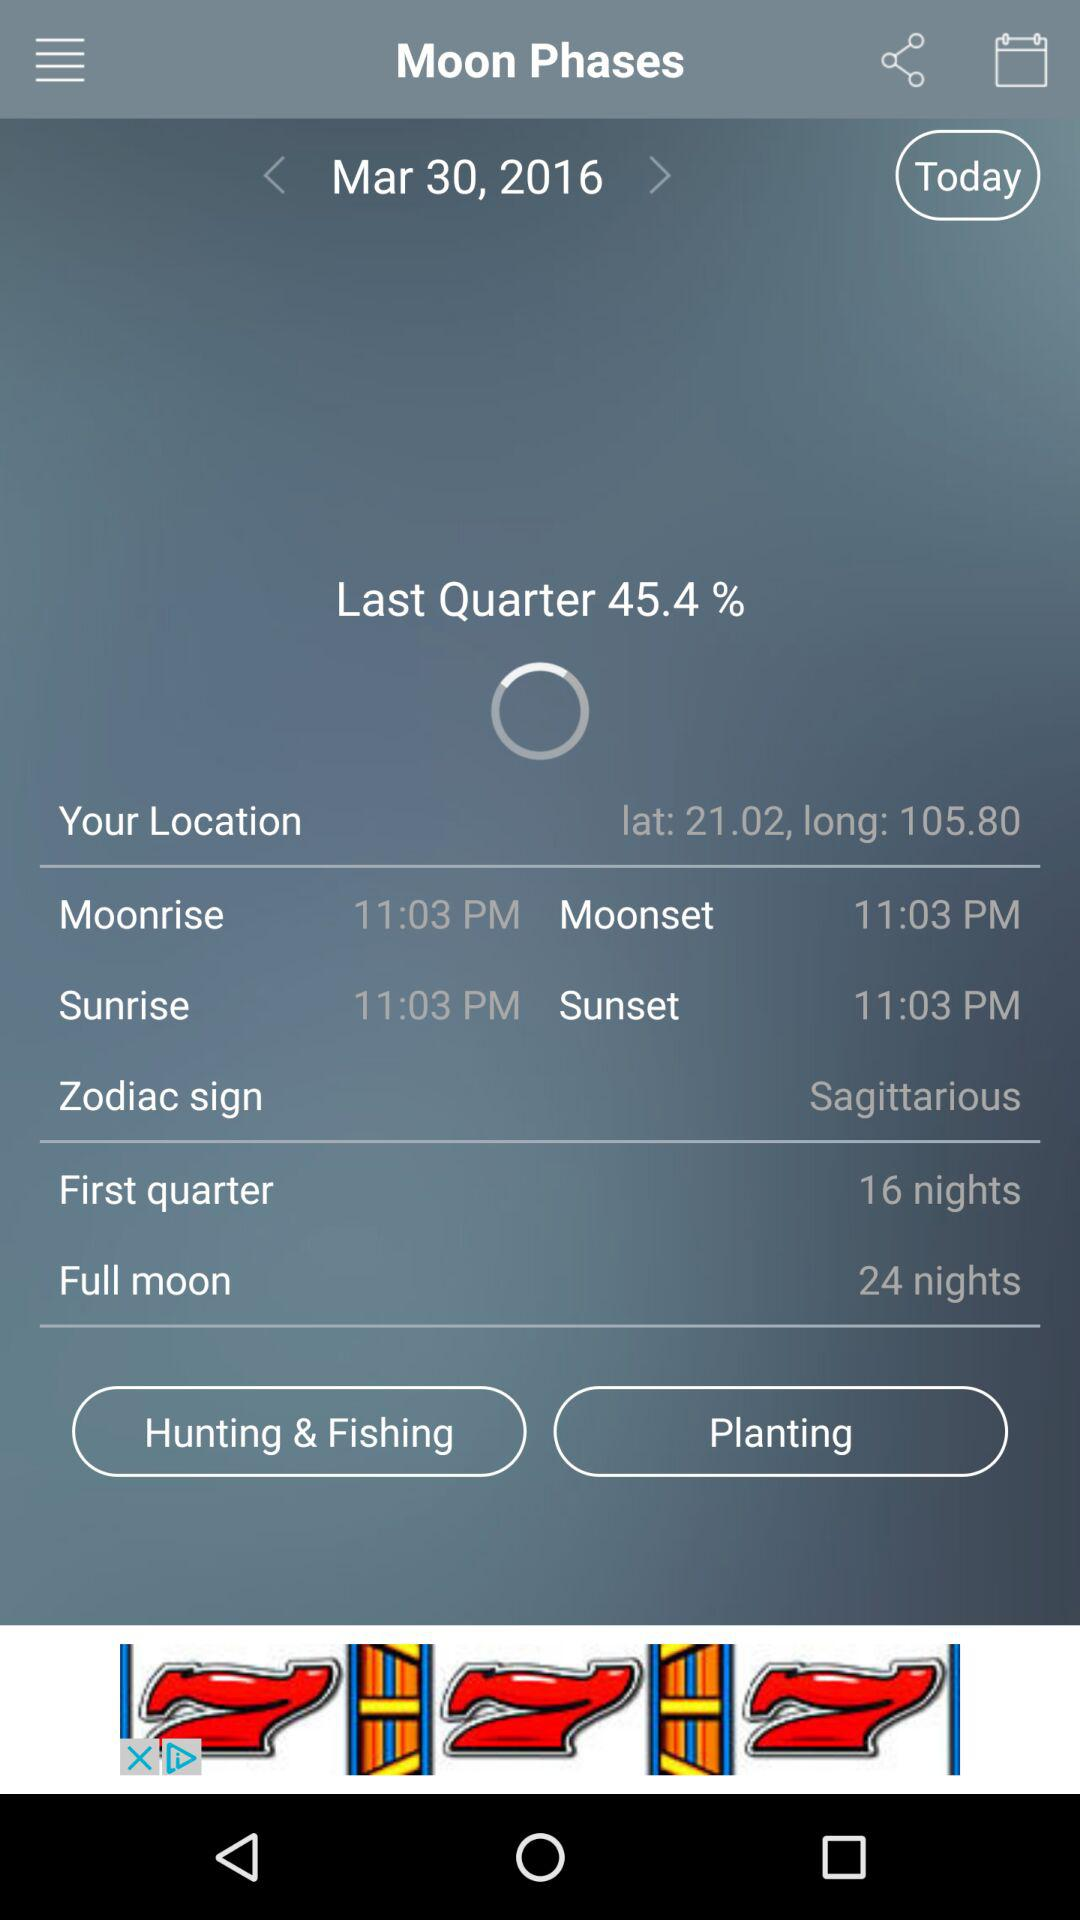What is the moonrise time? The moonrise time is 11:03 p.m. 